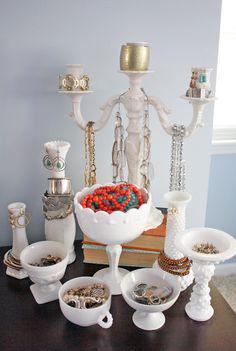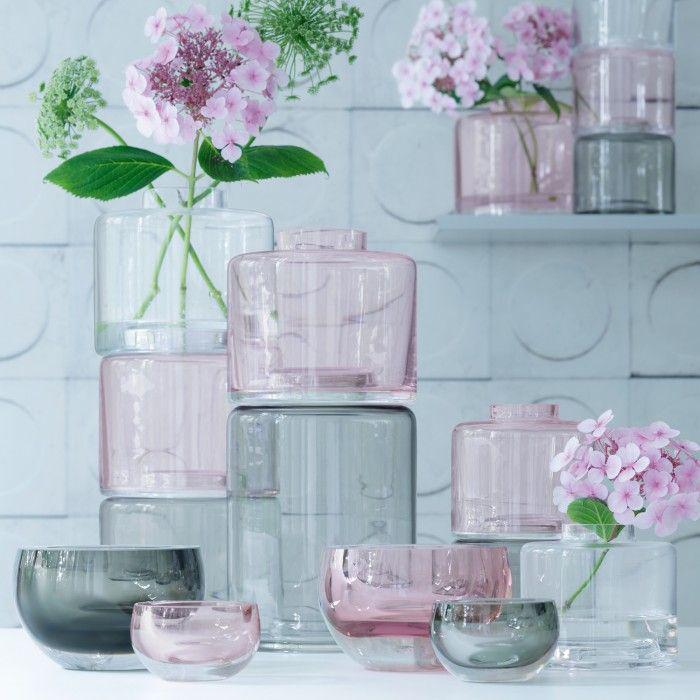The first image is the image on the left, the second image is the image on the right. For the images displayed, is the sentence "One photo shows at least three exclusively white opaque decorative containers that are not holding flowers." factually correct? Answer yes or no. Yes. The first image is the image on the left, the second image is the image on the right. Analyze the images presented: Is the assertion "Both images contain flowering plants in vertical containers." valid? Answer yes or no. No. 